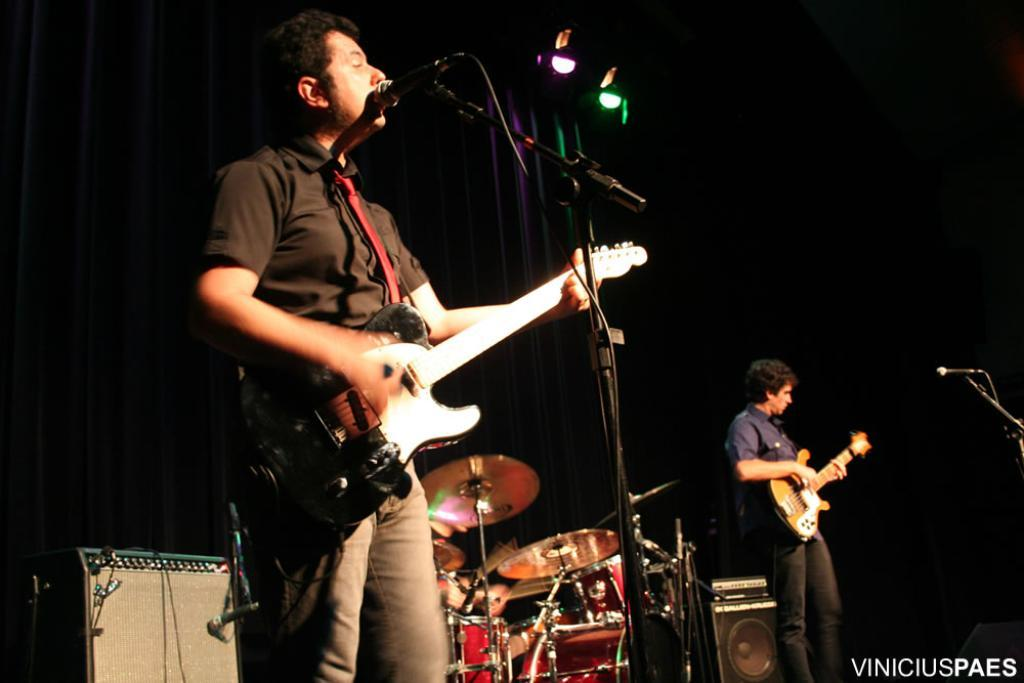What is the man in the image doing? The man is singing in the image. What is the man holding while singing? The man is holding a microphone. Are there any other musicians in the image? Yes, there is another man playing a guitar in the image. What can be seen in the background of the image? There is a drum set and two speakers in the background of the image. What type of mine can be seen in the background of the image? There is no mine present in the image; it features a man singing, a guitar player, and musical equipment in the background. 